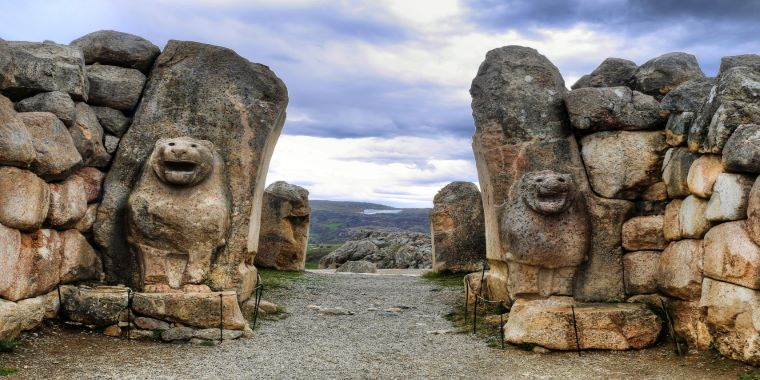Analyze the image in a comprehensive and detailed manner. The image features the iconic Lion Gate at Hattusa, the ancient capital of the Hittite Empire, located in present-day Turkey. This gate is renowned for its massive stone architecture and the pair of imposing lion sculptures that guard the entrance, symbolizing power and protection. Each lion is meticulously carved, with detailed manes and expressive faces, suggesting the artistry and technological capability of the Hittites around the 14th century BC. Behind the gate, undulating landscapes and a dynamic sky hint at the region's rugged terrain and weather patterns, elements that would have influenced the daily lives of its ancient inhabitants. Adding to its historical context, this gate was part of a larger fortification system, crucial for the defense of Hattusa against invaders, reflecting the geopolitical struggles of the era. 